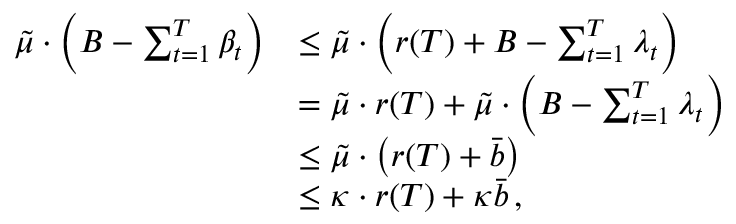Convert formula to latex. <formula><loc_0><loc_0><loc_500><loc_500>\begin{array} { r l } { \tilde { \mu } \cdot \left ( B - \sum _ { t = 1 } ^ { T } \beta _ { t } \right ) } & { \leq \tilde { \mu } \cdot \left ( r ( T ) + B - \sum _ { t = 1 } ^ { T } \lambda _ { t } \right ) } \\ & { = \tilde { \mu } \cdot r ( T ) + \tilde { \mu } \cdot \left ( B - \sum _ { t = 1 } ^ { T } \lambda _ { t } \right ) } \\ & { \leq \tilde { \mu } \cdot \left ( r ( T ) + \bar { b } \right ) } \\ & { \leq \kappa \cdot r ( T ) + \kappa \bar { b } \, , } \end{array}</formula> 